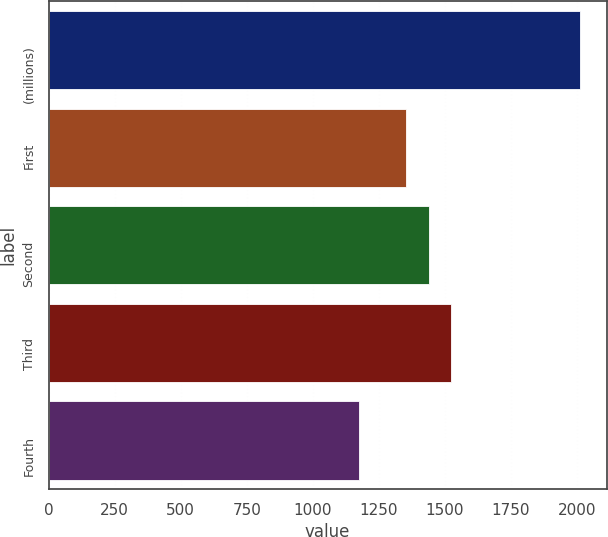<chart> <loc_0><loc_0><loc_500><loc_500><bar_chart><fcel>(millions)<fcel>First<fcel>Second<fcel>Third<fcel>Fourth<nl><fcel>2012<fcel>1353<fcel>1439<fcel>1522.6<fcel>1176<nl></chart> 